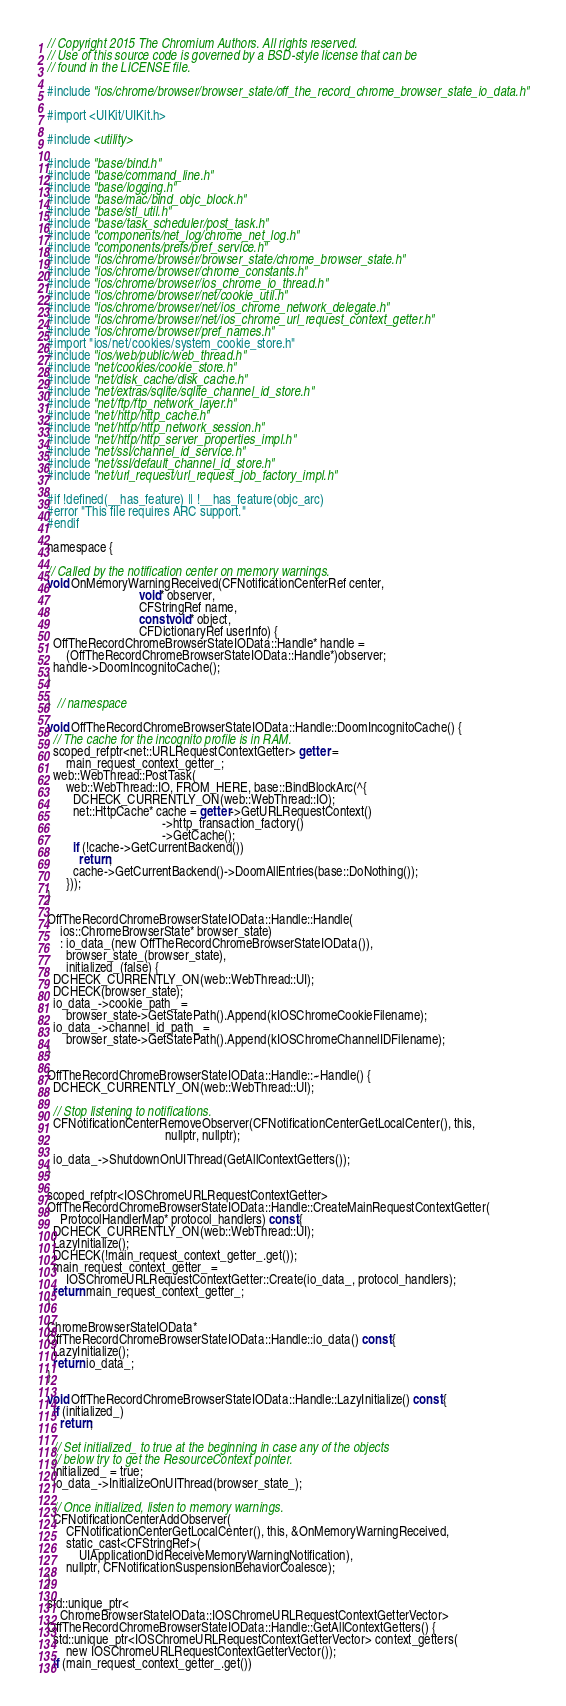<code> <loc_0><loc_0><loc_500><loc_500><_ObjectiveC_>// Copyright 2015 The Chromium Authors. All rights reserved.
// Use of this source code is governed by a BSD-style license that can be
// found in the LICENSE file.

#include "ios/chrome/browser/browser_state/off_the_record_chrome_browser_state_io_data.h"

#import <UIKit/UIKit.h>

#include <utility>

#include "base/bind.h"
#include "base/command_line.h"
#include "base/logging.h"
#include "base/mac/bind_objc_block.h"
#include "base/stl_util.h"
#include "base/task_scheduler/post_task.h"
#include "components/net_log/chrome_net_log.h"
#include "components/prefs/pref_service.h"
#include "ios/chrome/browser/browser_state/chrome_browser_state.h"
#include "ios/chrome/browser/chrome_constants.h"
#include "ios/chrome/browser/ios_chrome_io_thread.h"
#include "ios/chrome/browser/net/cookie_util.h"
#include "ios/chrome/browser/net/ios_chrome_network_delegate.h"
#include "ios/chrome/browser/net/ios_chrome_url_request_context_getter.h"
#include "ios/chrome/browser/pref_names.h"
#import "ios/net/cookies/system_cookie_store.h"
#include "ios/web/public/web_thread.h"
#include "net/cookies/cookie_store.h"
#include "net/disk_cache/disk_cache.h"
#include "net/extras/sqlite/sqlite_channel_id_store.h"
#include "net/ftp/ftp_network_layer.h"
#include "net/http/http_cache.h"
#include "net/http/http_network_session.h"
#include "net/http/http_server_properties_impl.h"
#include "net/ssl/channel_id_service.h"
#include "net/ssl/default_channel_id_store.h"
#include "net/url_request/url_request_job_factory_impl.h"

#if !defined(__has_feature) || !__has_feature(objc_arc)
#error "This file requires ARC support."
#endif

namespace {

// Called by the notification center on memory warnings.
void OnMemoryWarningReceived(CFNotificationCenterRef center,
                             void* observer,
                             CFStringRef name,
                             const void* object,
                             CFDictionaryRef userInfo) {
  OffTheRecordChromeBrowserStateIOData::Handle* handle =
      (OffTheRecordChromeBrowserStateIOData::Handle*)observer;
  handle->DoomIncognitoCache();
}

}  // namespace

void OffTheRecordChromeBrowserStateIOData::Handle::DoomIncognitoCache() {
  // The cache for the incognito profile is in RAM.
  scoped_refptr<net::URLRequestContextGetter> getter =
      main_request_context_getter_;
  web::WebThread::PostTask(
      web::WebThread::IO, FROM_HERE, base::BindBlockArc(^{
        DCHECK_CURRENTLY_ON(web::WebThread::IO);
        net::HttpCache* cache = getter->GetURLRequestContext()
                                    ->http_transaction_factory()
                                    ->GetCache();
        if (!cache->GetCurrentBackend())
          return;
        cache->GetCurrentBackend()->DoomAllEntries(base::DoNothing());
      }));
}

OffTheRecordChromeBrowserStateIOData::Handle::Handle(
    ios::ChromeBrowserState* browser_state)
    : io_data_(new OffTheRecordChromeBrowserStateIOData()),
      browser_state_(browser_state),
      initialized_(false) {
  DCHECK_CURRENTLY_ON(web::WebThread::UI);
  DCHECK(browser_state);
  io_data_->cookie_path_ =
      browser_state->GetStatePath().Append(kIOSChromeCookieFilename);
  io_data_->channel_id_path_ =
      browser_state->GetStatePath().Append(kIOSChromeChannelIDFilename);
}

OffTheRecordChromeBrowserStateIOData::Handle::~Handle() {
  DCHECK_CURRENTLY_ON(web::WebThread::UI);

  // Stop listening to notifications.
  CFNotificationCenterRemoveObserver(CFNotificationCenterGetLocalCenter(), this,
                                     nullptr, nullptr);

  io_data_->ShutdownOnUIThread(GetAllContextGetters());
}

scoped_refptr<IOSChromeURLRequestContextGetter>
OffTheRecordChromeBrowserStateIOData::Handle::CreateMainRequestContextGetter(
    ProtocolHandlerMap* protocol_handlers) const {
  DCHECK_CURRENTLY_ON(web::WebThread::UI);
  LazyInitialize();
  DCHECK(!main_request_context_getter_.get());
  main_request_context_getter_ =
      IOSChromeURLRequestContextGetter::Create(io_data_, protocol_handlers);
  return main_request_context_getter_;
}

ChromeBrowserStateIOData*
OffTheRecordChromeBrowserStateIOData::Handle::io_data() const {
  LazyInitialize();
  return io_data_;
}

void OffTheRecordChromeBrowserStateIOData::Handle::LazyInitialize() const {
  if (initialized_)
    return;

  // Set initialized_ to true at the beginning in case any of the objects
  // below try to get the ResourceContext pointer.
  initialized_ = true;
  io_data_->InitializeOnUIThread(browser_state_);

  // Once initialized, listen to memory warnings.
  CFNotificationCenterAddObserver(
      CFNotificationCenterGetLocalCenter(), this, &OnMemoryWarningReceived,
      static_cast<CFStringRef>(
          UIApplicationDidReceiveMemoryWarningNotification),
      nullptr, CFNotificationSuspensionBehaviorCoalesce);
}

std::unique_ptr<
    ChromeBrowserStateIOData::IOSChromeURLRequestContextGetterVector>
OffTheRecordChromeBrowserStateIOData::Handle::GetAllContextGetters() {
  std::unique_ptr<IOSChromeURLRequestContextGetterVector> context_getters(
      new IOSChromeURLRequestContextGetterVector());
  if (main_request_context_getter_.get())</code> 